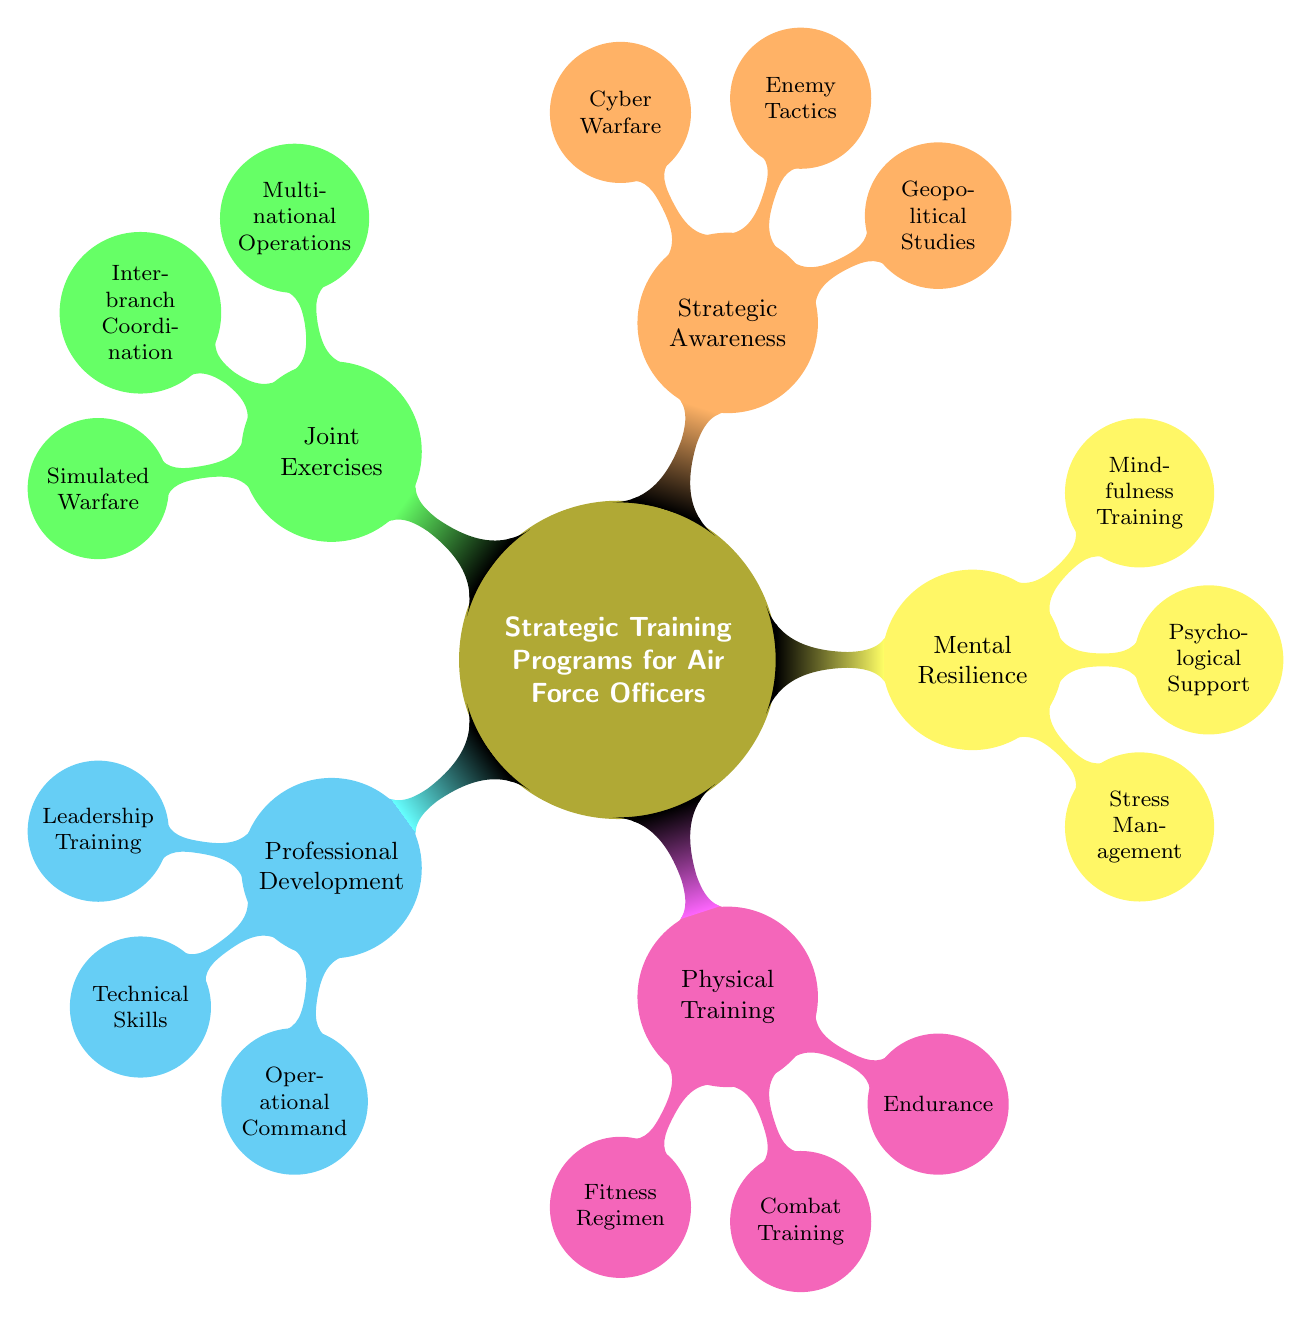What is the main topic of the mind map? The main topic is indicated at the center of the mind map, which is "Strategic Training Programs for Air Force Officers."
Answer: Strategic Training Programs for Air Force Officers How many main categories are there in the mind map? The main categories can be counted as they branch directly from the center node, and there are five categories: Professional Development, Physical Training, Mental Resilience, Strategic Awareness, and Joint Exercises.
Answer: 5 What training falls under the 'Professional Development' category? The 'Professional Development' category has three direct children nodes: Leadership Training, Technical Skills, and Operational Command, representing different training areas.
Answer: Leadership Training, Technical Skills, Operational Command Which category includes 'Mindfulness Training'? 'Mindfulness Training' is a child node under the 'Mental Resilience' category. This can be confirmed by tracing the path from the main topic to its placement in the diagram.
Answer: Mental Resilience What is the purpose of 'Simulated Warfare'? 'Simulated Warfare' is listed under 'Joint Exercises,' indicating that it relates to training exercises designed to simulate combat scenarios for practice and preparedness.
Answer: Joint Exercises How many child nodes are associated with the 'Strategic Awareness' category? The 'Strategic Awareness' category has three child nodes: Geopolitical Studies, Enemy Tactics, and Cyber Warfare, which can be counted directly from the diagram structure.
Answer: 3 Which training program focuses on fitness? The 'Fitness Regimen' is specified as focusing on fitness under the 'Physical Training' category. The direct relationship can be established by locating it in the mind map.
Answer: Fitness Regimen What is the connection between 'Multinational Operations' and 'Joint Exercises'? 'Multinational Operations' is a child node under the 'Joint Exercises' category, showing it is specifically related to training activities that involve multiple nations' forces.
Answer: Joint Exercises Which institution is responsible for 'Cyber Warfare' training? The node 'Cyber Warfare' mentions that the training is provided by the Totalförsvarets forskningsinstitut, directly linking the training to a specific institution as indicated in the diagram.
Answer: Totalförsvarets forskningsinstitut 